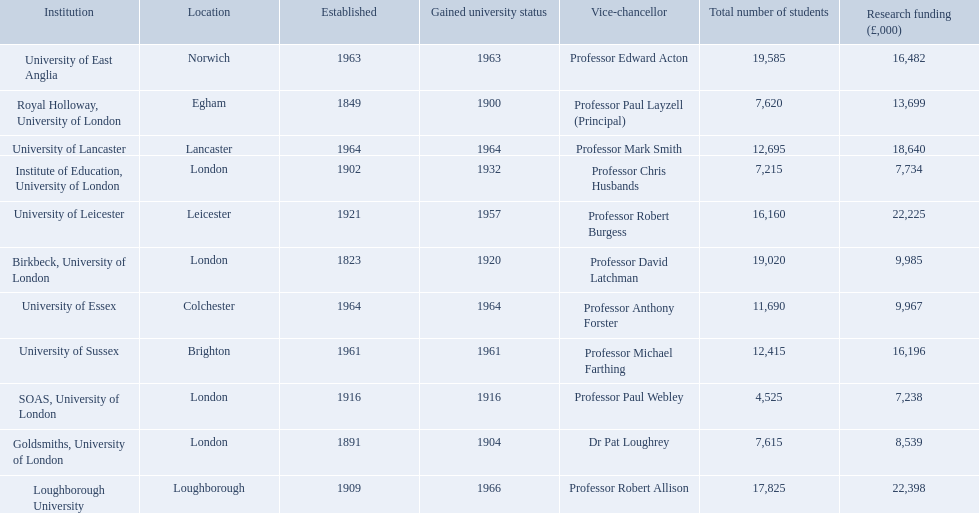Where is birbeck,university of london located? London. Which university was established in 1921? University of Leicester. Which institution gained university status recently? Loughborough University. 